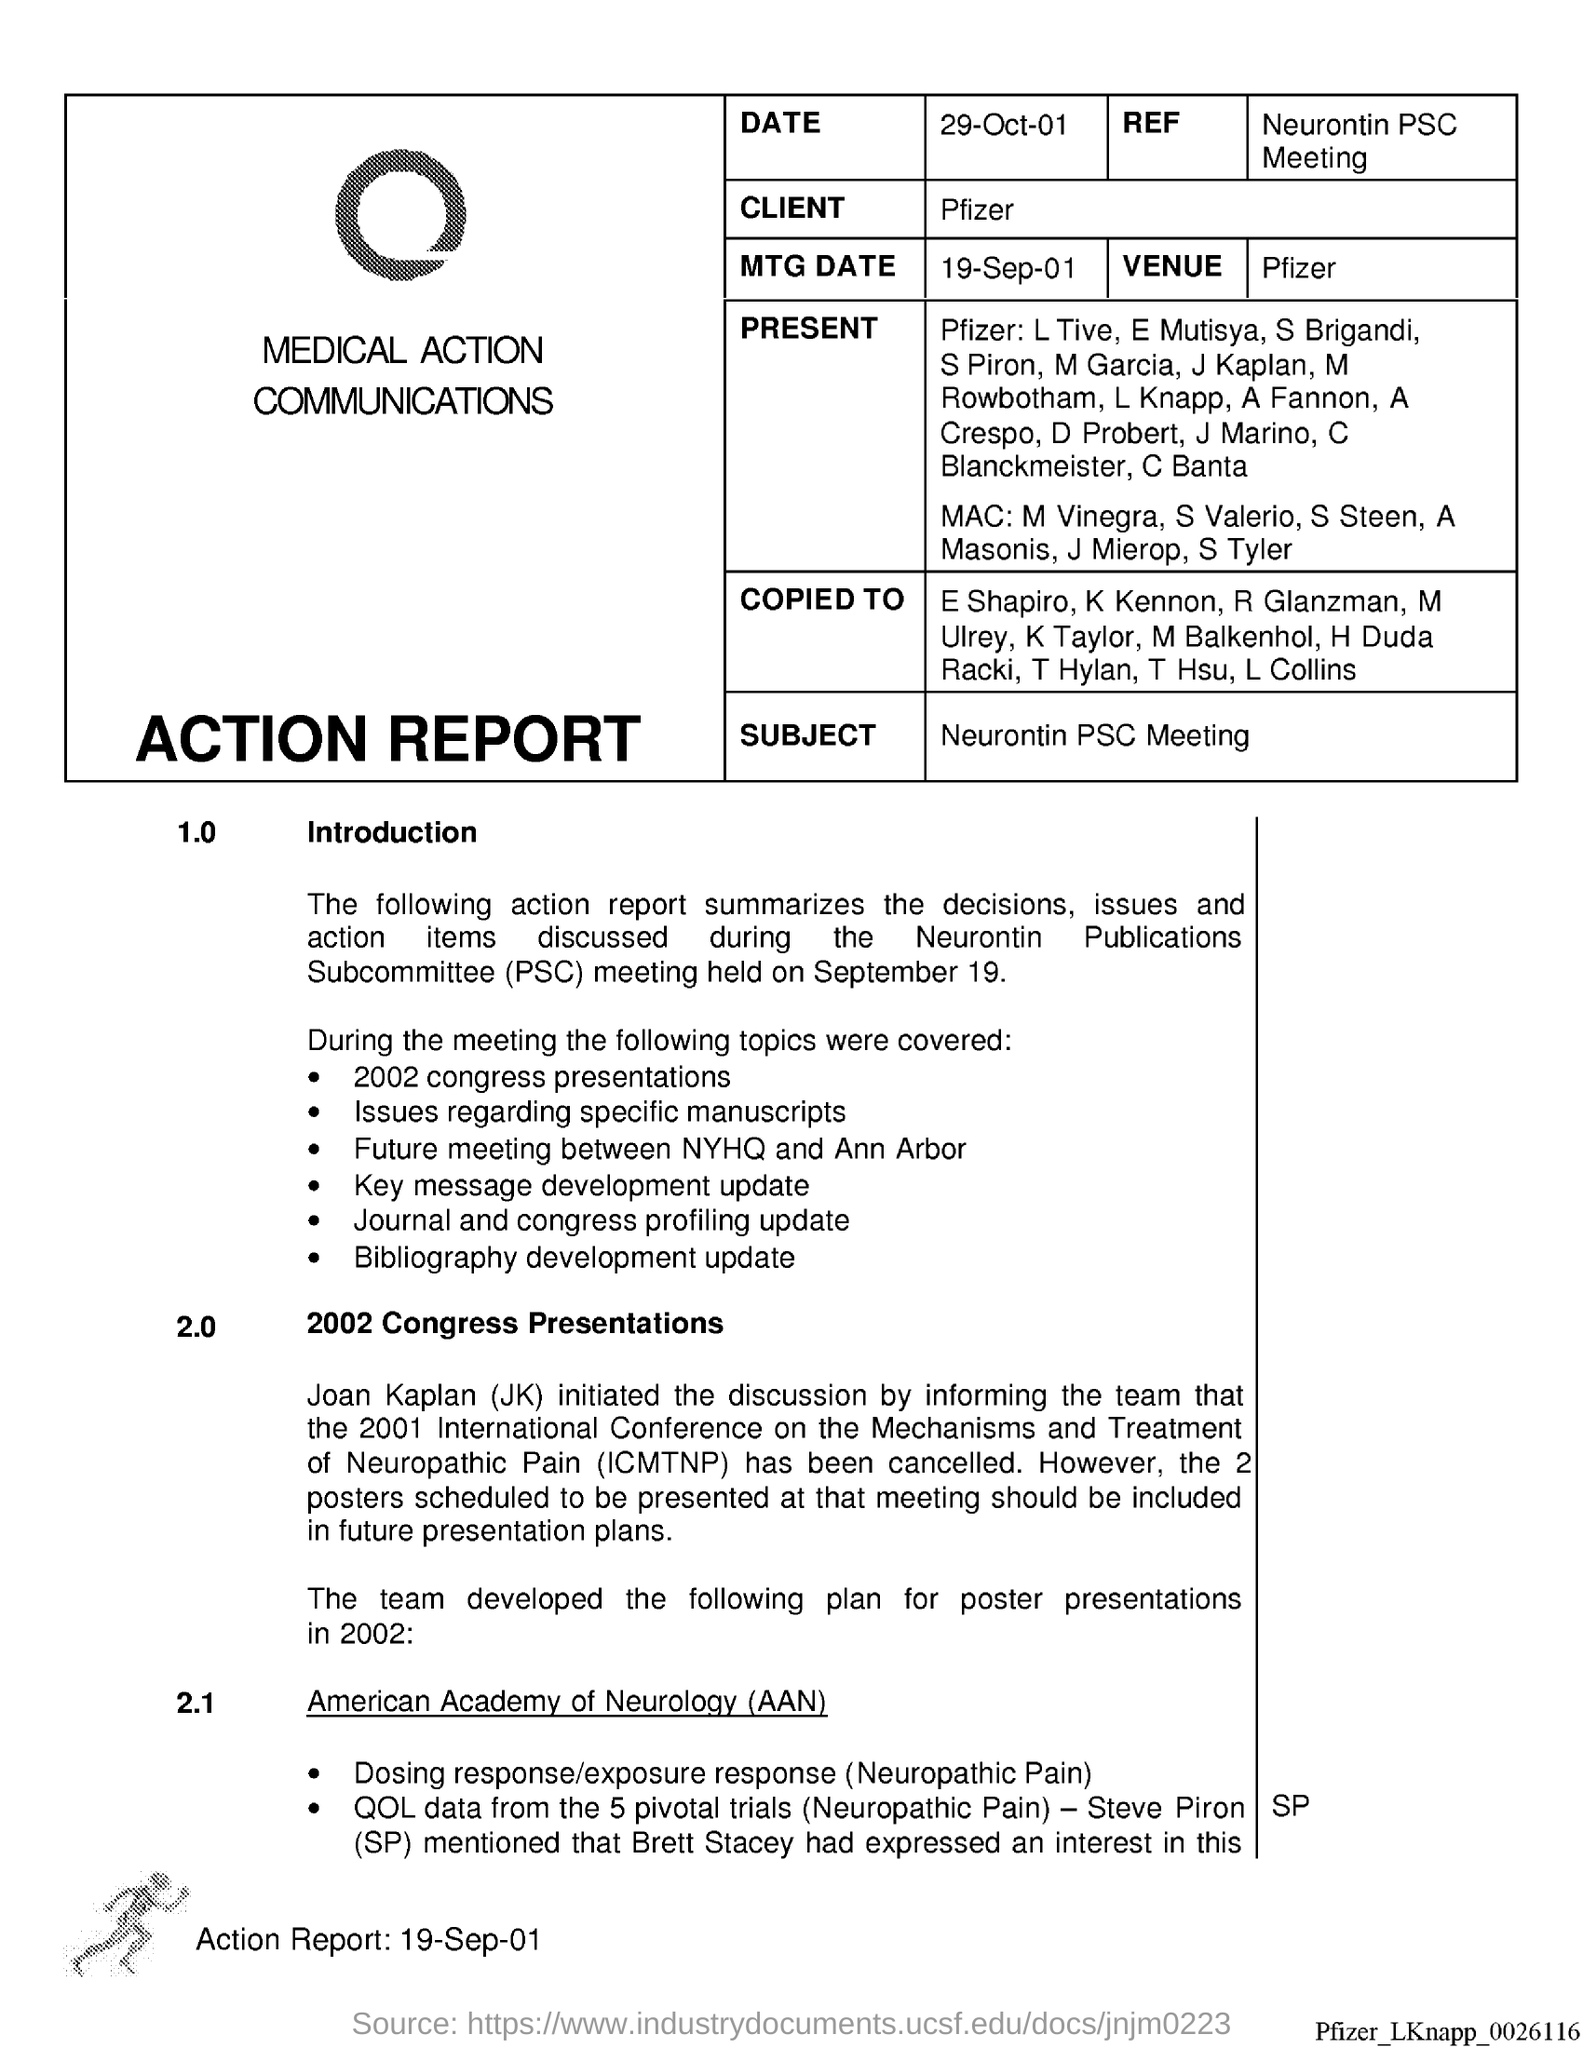What is the date in action report?
Give a very brief answer. 29-Oct-01. What does aan stands for?
Your answer should be compact. American academy of neurology. What does psc stand for ?
Your answer should be compact. Publications Subcommittee. What does jk stand for ?
Offer a terse response. Joan Kaplan. What does icmtnp stand for ?
Make the answer very short. International conference on the mechanisms and treatment of neuropathic pain. What is the subject of action report ?
Your response must be concise. Neurontin PSC meeting. What is the mtg date in action report ?
Your answer should be very brief. 19-sep-01. What does sp stands for ?
Give a very brief answer. Steve Piron. 